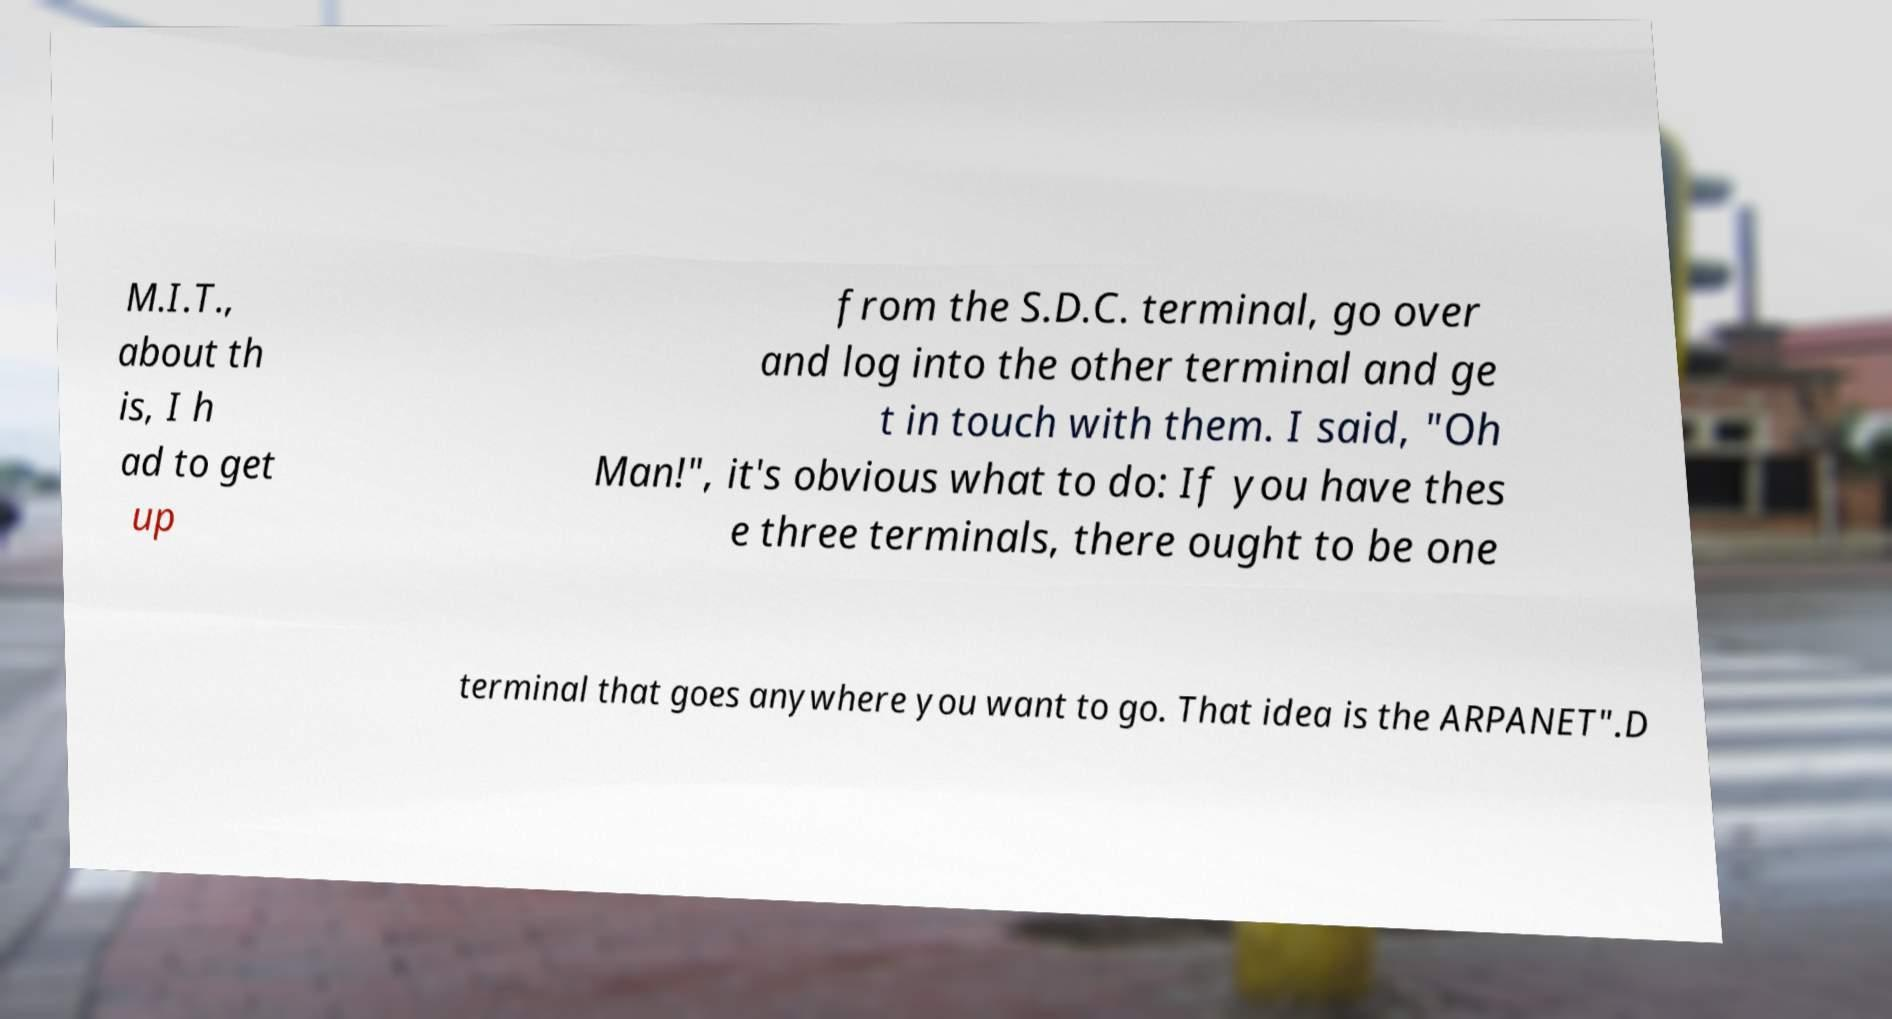Please identify and transcribe the text found in this image. M.I.T., about th is, I h ad to get up from the S.D.C. terminal, go over and log into the other terminal and ge t in touch with them. I said, "Oh Man!", it's obvious what to do: If you have thes e three terminals, there ought to be one terminal that goes anywhere you want to go. That idea is the ARPANET".D 